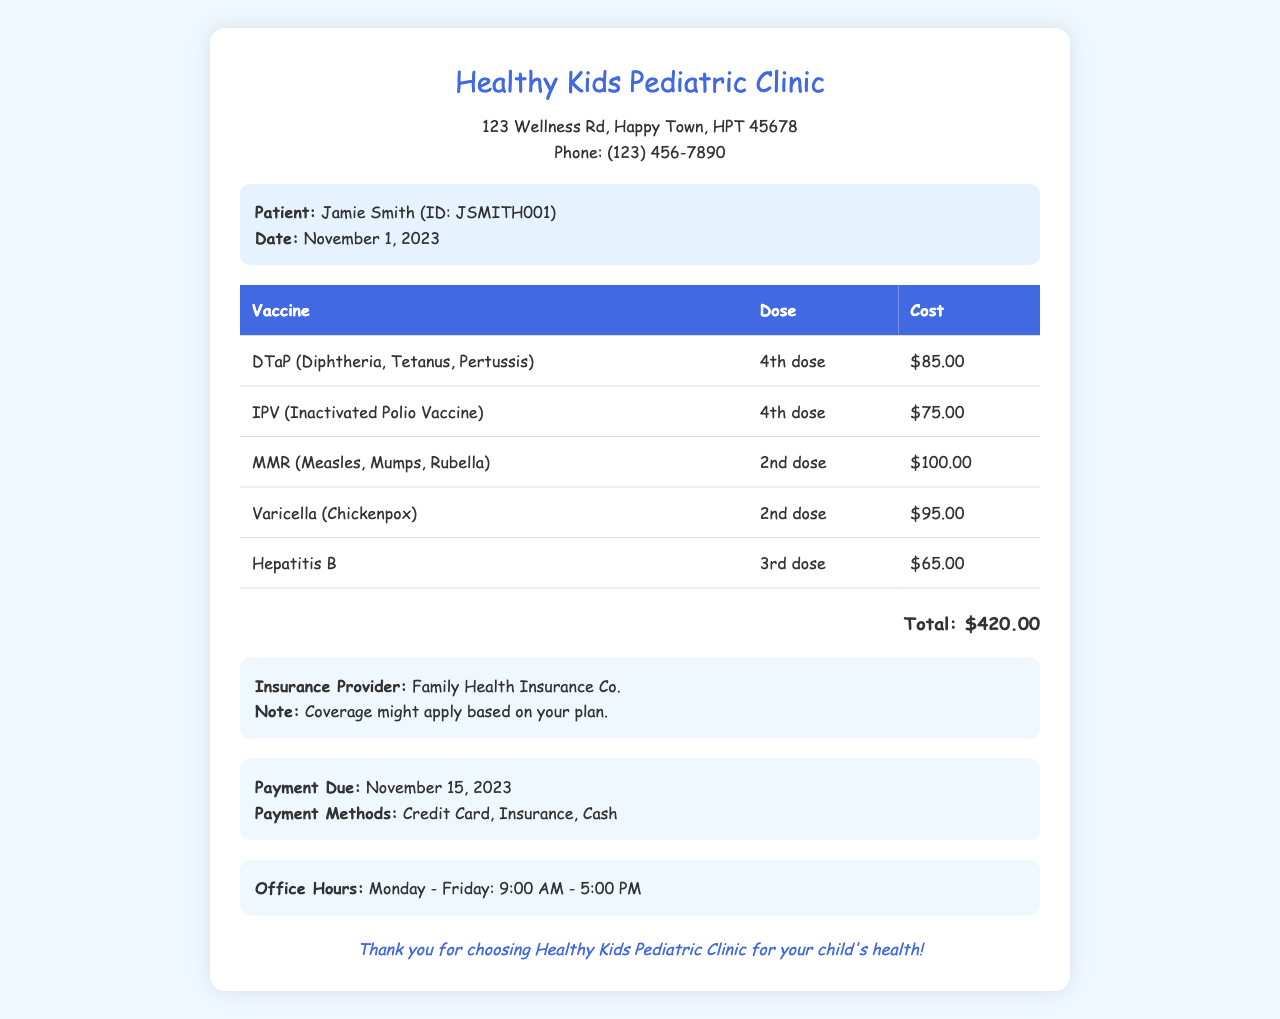What is the name of the clinic? The clinic's name is displayed prominently at the top of the document.
Answer: Healthy Kids Pediatric Clinic What is the total cost for the vaccines? The total cost is calculated at the end of the list of vaccines.
Answer: $420.00 When is the payment due? The payment due date is mentioned in the payment information section.
Answer: November 15, 2023 Who is the insurance provider? The insurance provider is listed in the insurance information section of the document.
Answer: Family Health Insurance Co How many doses of DTaP are included in the invoice? The invoice specifies the dose for each vaccine in the table.
Answer: 4th dose What is the cost of the Hepatitis B vaccine? The table lists the cost of each vaccine individually.
Answer: $65.00 What are the payment methods accepted? The payment information section lists the available payment methods.
Answer: Credit Card, Insurance, Cash What date was the vaccination given? The date is mentioned in the patient info section of the document.
Answer: November 1, 2023 What is the total number of different vaccines listed in the invoice? The document lists each vaccine in a row of the table, which can be counted.
Answer: 5 